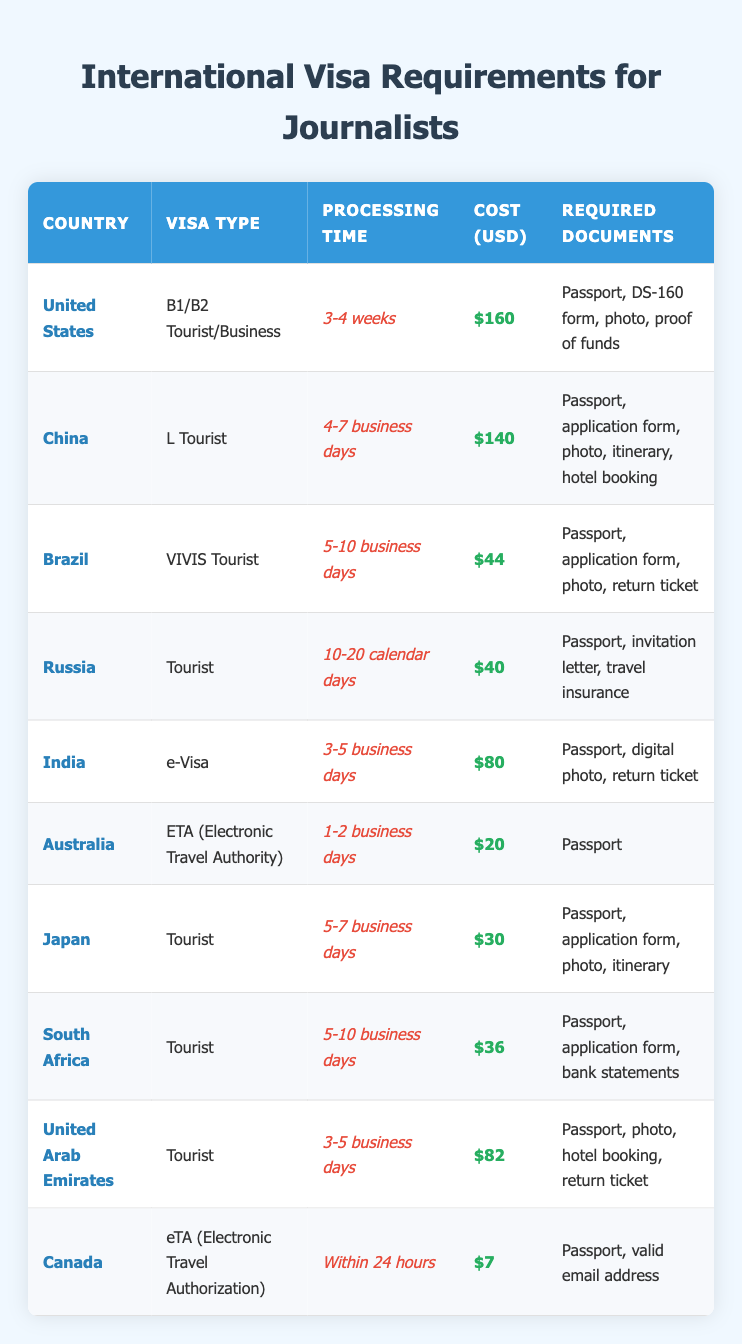What is the processing time for a tourist visa to China? The table shows that the processing time for a tourist visa to China is listed as "4-7 business days."
Answer: 4-7 business days What are the required documents for an e-Visa to India? According to the table, the required documents for an e-Visa to India include "Passport, digital photo, return ticket."
Answer: Passport, digital photo, return ticket Which country has the highest visa cost? By examining the cost column, the highest cost is $160 for a B1/B2 Tourist/Business visa to the United States.
Answer: $160 Is the processing time for Japan's tourist visa shorter than that for Brazil's? The processing time for Japan is "5-7 business days" and for Brazil, it is "5-10 business days." Since 5-7 is less than 5-10, the processing time for Japan is indeed shorter.
Answer: Yes What is the average cost of a tourist visa for the countries listed? First, we add all the visa costs: 160 + 140 + 44 + 40 + 80 + 20 + 30 + 36 + 82 + 7 = 639. There are 10 countries, resulting in an average of 639/10 = 63.9.
Answer: 63.9 How many countries require an invitation letter for a tourist visa? Only Russia requires an invitation letter as per the required documents listed in the table. Checking each country's requirements, we find that Russia is the sole entry.
Answer: 1 What is the processing time for the eTA to Canada? The table indicates that the processing time for the eTA to Canada is "Within 24 hours."
Answer: Within 24 hours Which visa type is the cheapest among the listed countries? The table shows that the cheapest visa is the eTA to Canada at $7.
Answer: $7 How many countries have a processing time of more than 10 days for their visa? From the table, we see that only Russia has a processing time of "10-20 calendar days." Since this is the only entry over 10 days, the total count is one.
Answer: 1 